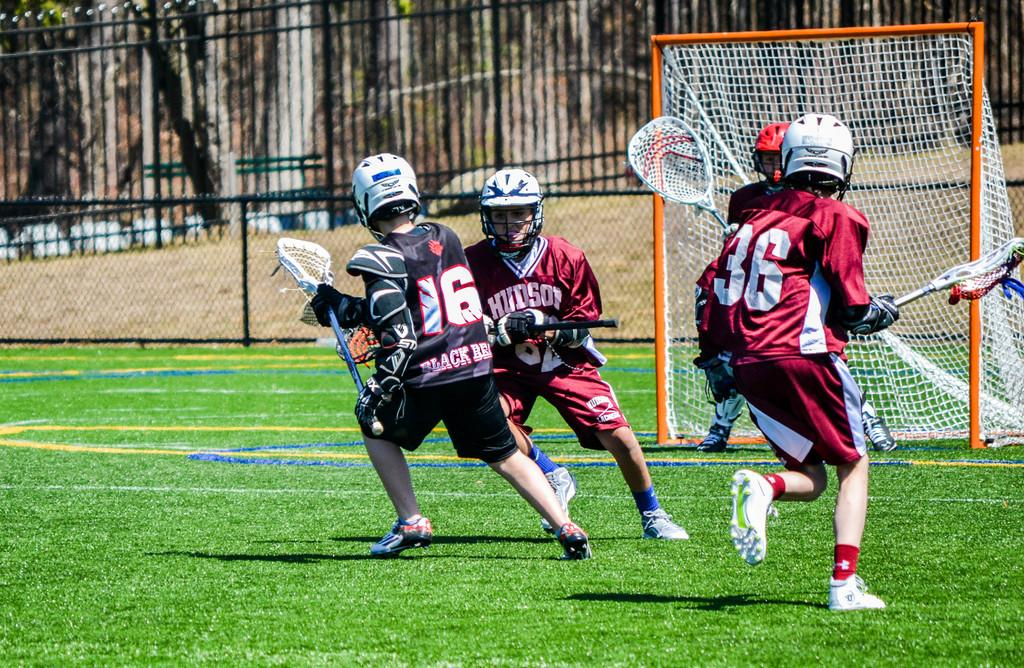What are the people in the image doing? There are players on the ground in the image, suggesting they are engaged in a game or sport. What can be seen surrounding the players in the image? There is a fence visible in the image, which may indicate a boundary or playing area. What type of surface are the players on? There is grass in the image, which is likely the playing surface. What type of waves can be seen crashing on the shore in the image? There are no waves or shore visible in the image; it features players on the ground with a fence and grass. 